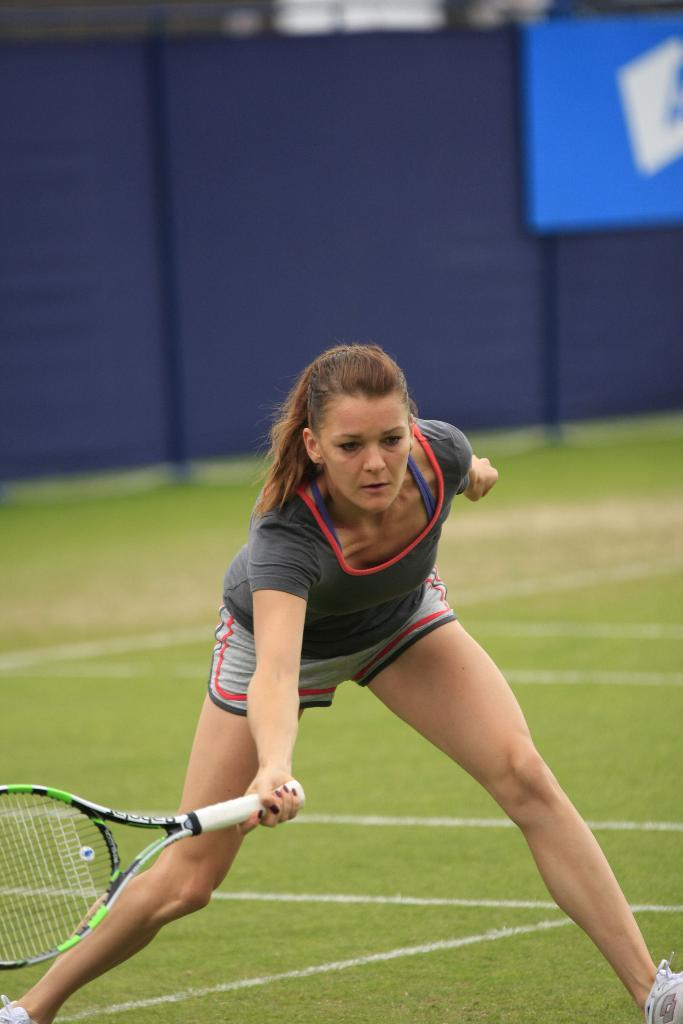Who is the main subject in the image? There is a woman in the image. What is the woman doing in the image? The woman is playing a game. What object is the woman holding in the image? The woman is holding a bat. What type of surface is visible in the image? There is ground visible in the image. What can be seen in the background of the image? There is a hoarding in the image. What type of badge is the woman wearing in the image? There is no badge visible on the woman in the image. Where is the woman planning to go on vacation in the image? The image does not provide any information about the woman's vacation plans. 